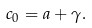<formula> <loc_0><loc_0><loc_500><loc_500>c _ { 0 } = a + \gamma .</formula> 